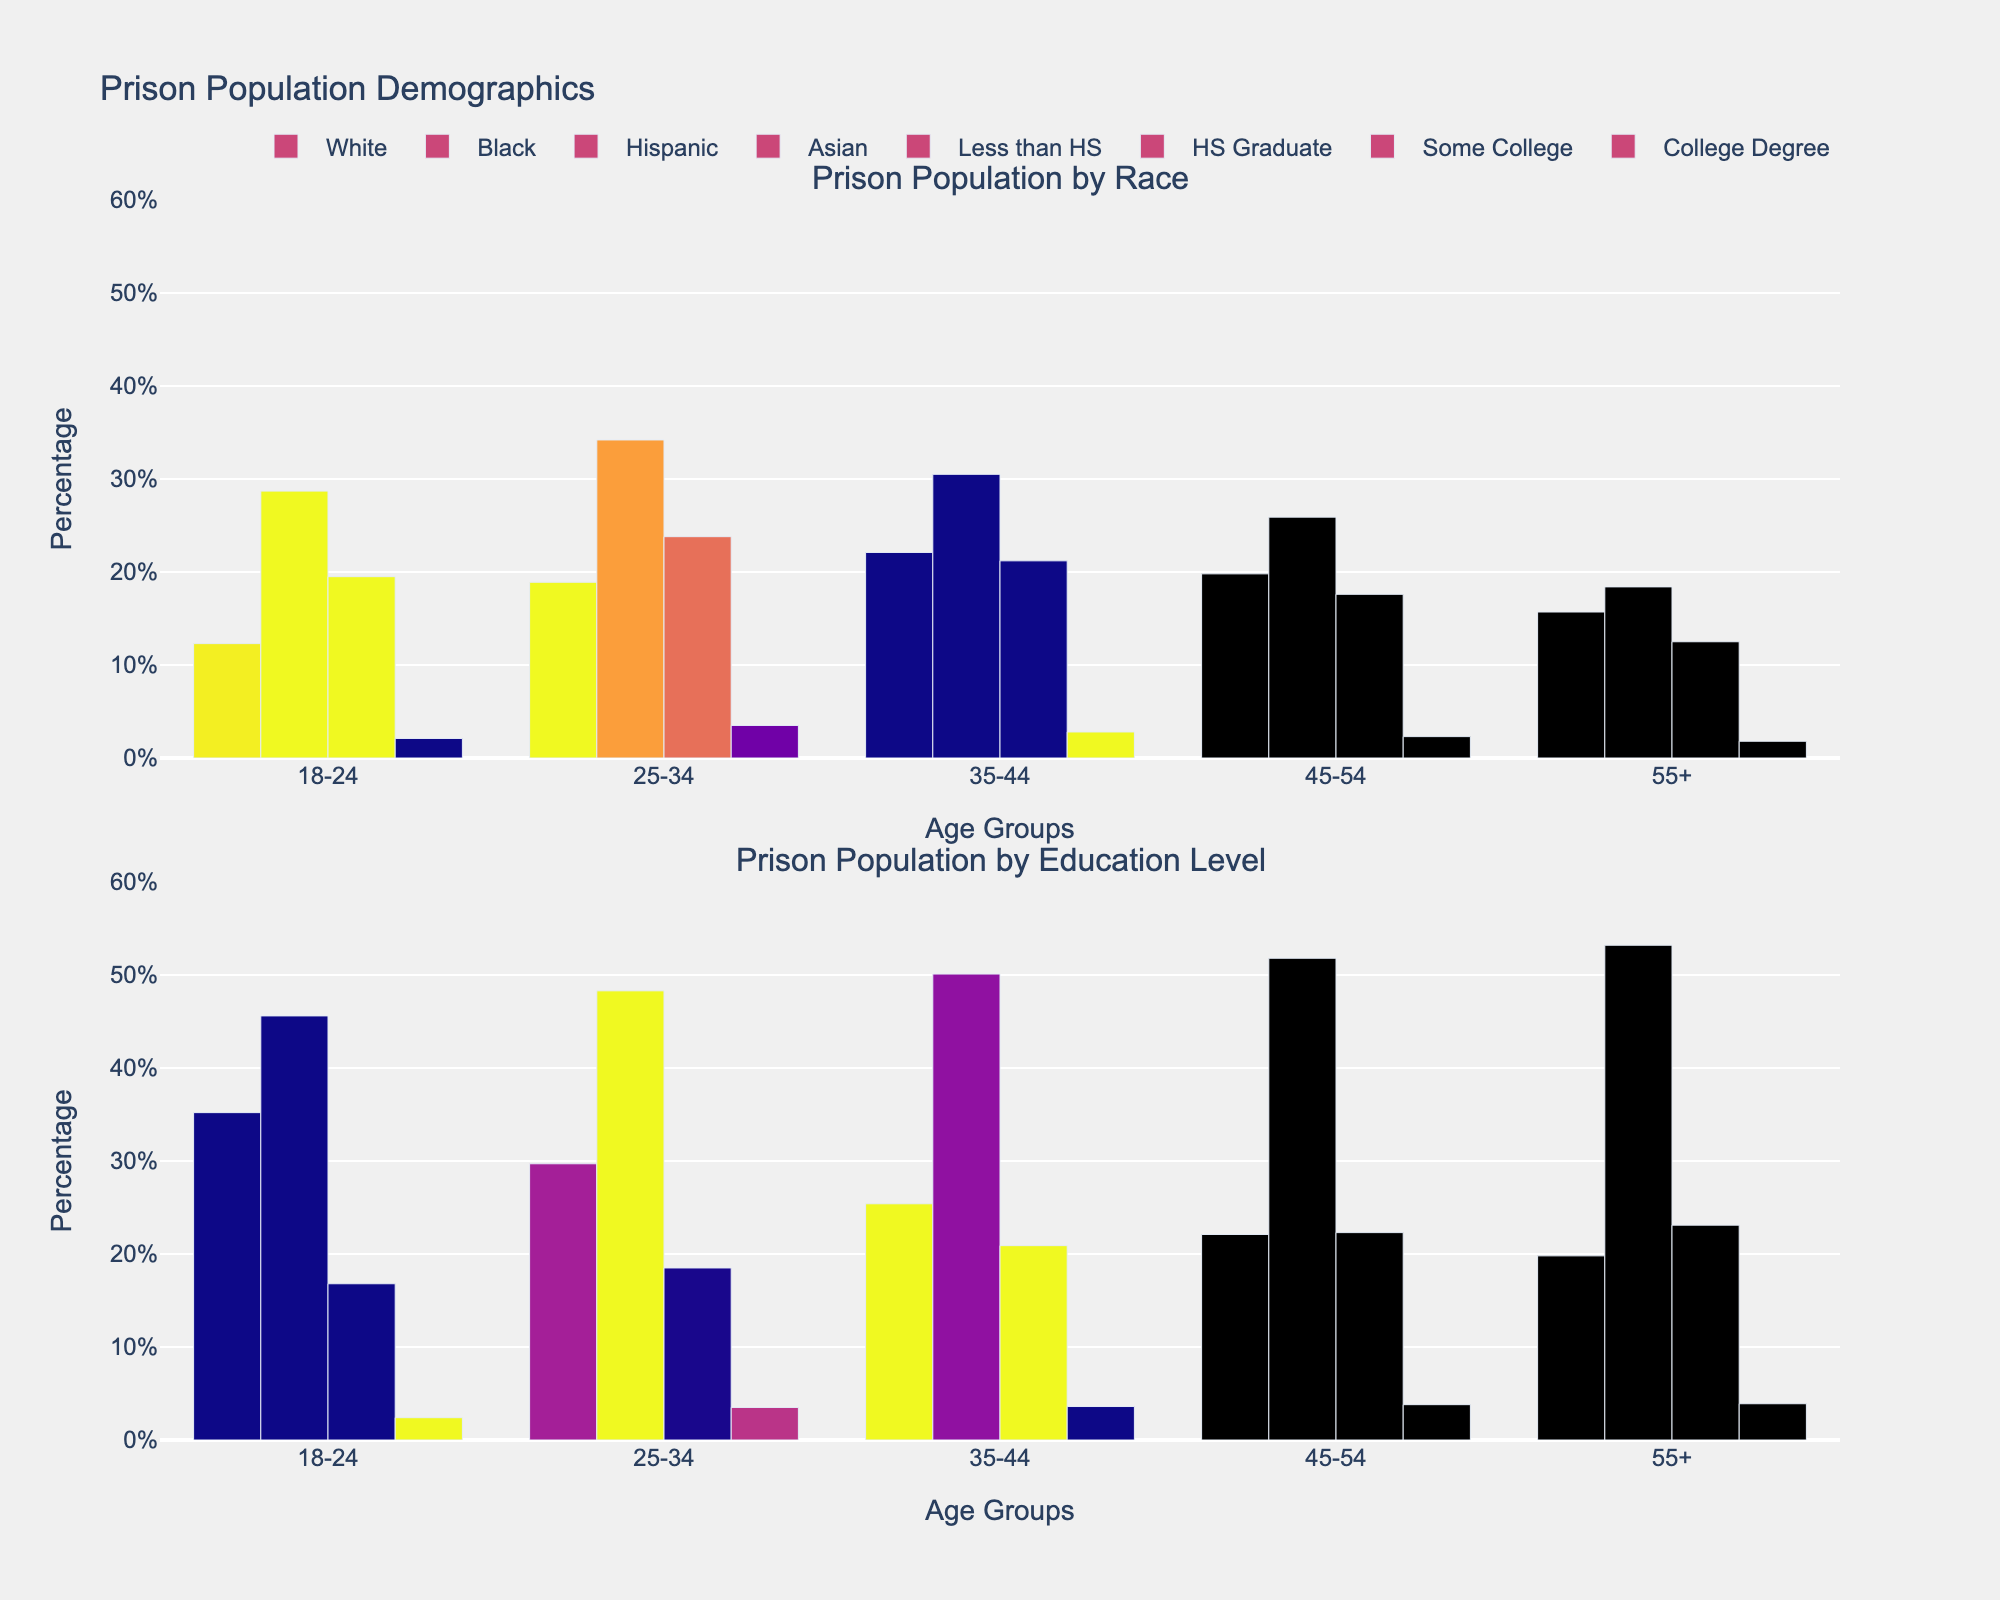What age group has the highest percentage of Black prisoners? Look at the first subplot titled "Prison Population by Race" and compare the heights of the bars representing Black prisoners. The tallest bar is found in the 25-34 age group.
Answer: 25-34 Among the age groups, which has the lowest percentage of prisoners with a College Degree? Refer to the second subplot titled "Prison Population by Education Level" and identify the shortest bar corresponding to College Degree. This is found in the 18-24 age group.
Answer: 18-24 Which race has the highest percentage in the 35-44 age group? Check the first subplot and compare the bar heights for all races in the 35-44 age group. The White race has the highest percentage.
Answer: White Compare the percentages of Hispanic prisoners in the 18-24 and 25-34 age groups. Which group has a higher percentage? Examine the heights of the bars for Hispanic prisoners in both age groups in the first subplot. The 25-34 age group has a higher percentage.
Answer: 25-34 What is the percentage difference between prisoners aged 55+ with "Some College" education and "Less than HS" education? In the second subplot, find the heights of the bars representing "Some College" and "Less than HS" for the 55+ age group. The difference is 23.1% (Some College) - 19.8% (Less than HS) = 3.3%.
Answer: 3.3% Is there an age group where the percentage of Asian prisoners is higher than the percentage of prisoners with a College Degree? In both subplots, compare the bars for Asian prisoners and College Degree in each age group. For each age group, the Asian prisoner percentage is always greater than or equal to the percentage of College Degree.
Answer: Yes In the 45-54 age group, which education level has the highest percentage? Check the second subplot and compare the bars for different education levels within the 45-54 age group. The "HS Graduate" category has the highest percentage.
Answer: HS Graduate Compare the White and Black prison populations across all age groups. In which age group is this disparity the largest? By observing the first subplot, calculate the differences between the White and Black bars for each age group. The largest disparity is in the 18-24 age group (28.7% - 12.3% = 16.4%).
Answer: 18-24 